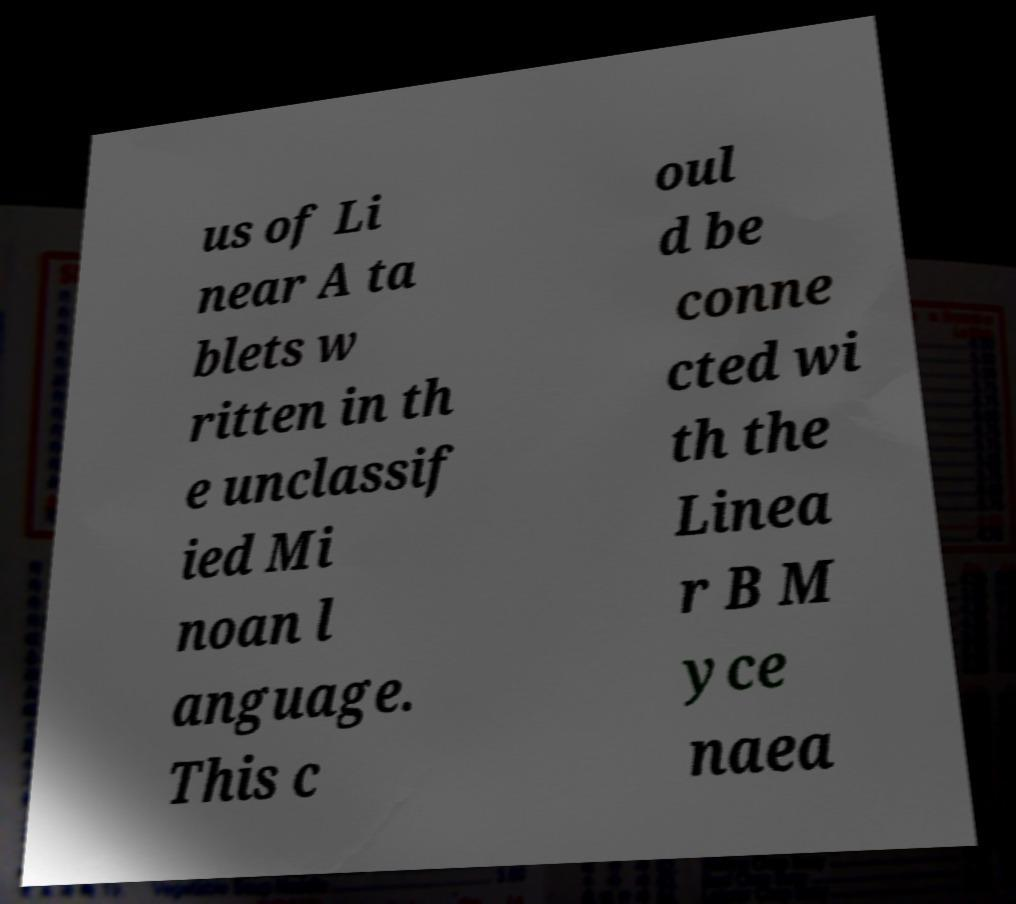Can you accurately transcribe the text from the provided image for me? us of Li near A ta blets w ritten in th e unclassif ied Mi noan l anguage. This c oul d be conne cted wi th the Linea r B M yce naea 